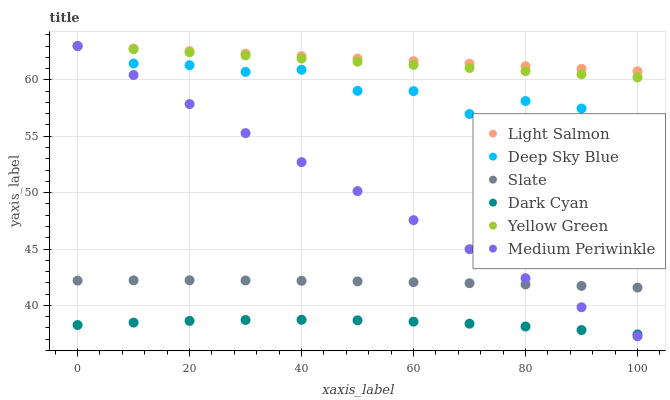Does Dark Cyan have the minimum area under the curve?
Answer yes or no. Yes. Does Light Salmon have the maximum area under the curve?
Answer yes or no. Yes. Does Yellow Green have the minimum area under the curve?
Answer yes or no. No. Does Yellow Green have the maximum area under the curve?
Answer yes or no. No. Is Medium Periwinkle the smoothest?
Answer yes or no. Yes. Is Deep Sky Blue the roughest?
Answer yes or no. Yes. Is Yellow Green the smoothest?
Answer yes or no. No. Is Yellow Green the roughest?
Answer yes or no. No. Does Medium Periwinkle have the lowest value?
Answer yes or no. Yes. Does Yellow Green have the lowest value?
Answer yes or no. No. Does Deep Sky Blue have the highest value?
Answer yes or no. Yes. Does Slate have the highest value?
Answer yes or no. No. Is Dark Cyan less than Deep Sky Blue?
Answer yes or no. Yes. Is Light Salmon greater than Dark Cyan?
Answer yes or no. Yes. Does Medium Periwinkle intersect Slate?
Answer yes or no. Yes. Is Medium Periwinkle less than Slate?
Answer yes or no. No. Is Medium Periwinkle greater than Slate?
Answer yes or no. No. Does Dark Cyan intersect Deep Sky Blue?
Answer yes or no. No. 